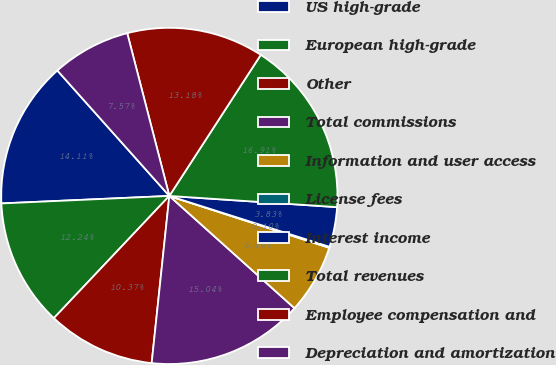<chart> <loc_0><loc_0><loc_500><loc_500><pie_chart><fcel>US high-grade<fcel>European high-grade<fcel>Other<fcel>Total commissions<fcel>Information and user access<fcel>License fees<fcel>Interest income<fcel>Total revenues<fcel>Employee compensation and<fcel>Depreciation and amortization<nl><fcel>14.11%<fcel>12.24%<fcel>10.37%<fcel>15.04%<fcel>6.64%<fcel>0.1%<fcel>3.83%<fcel>16.91%<fcel>13.18%<fcel>7.57%<nl></chart> 